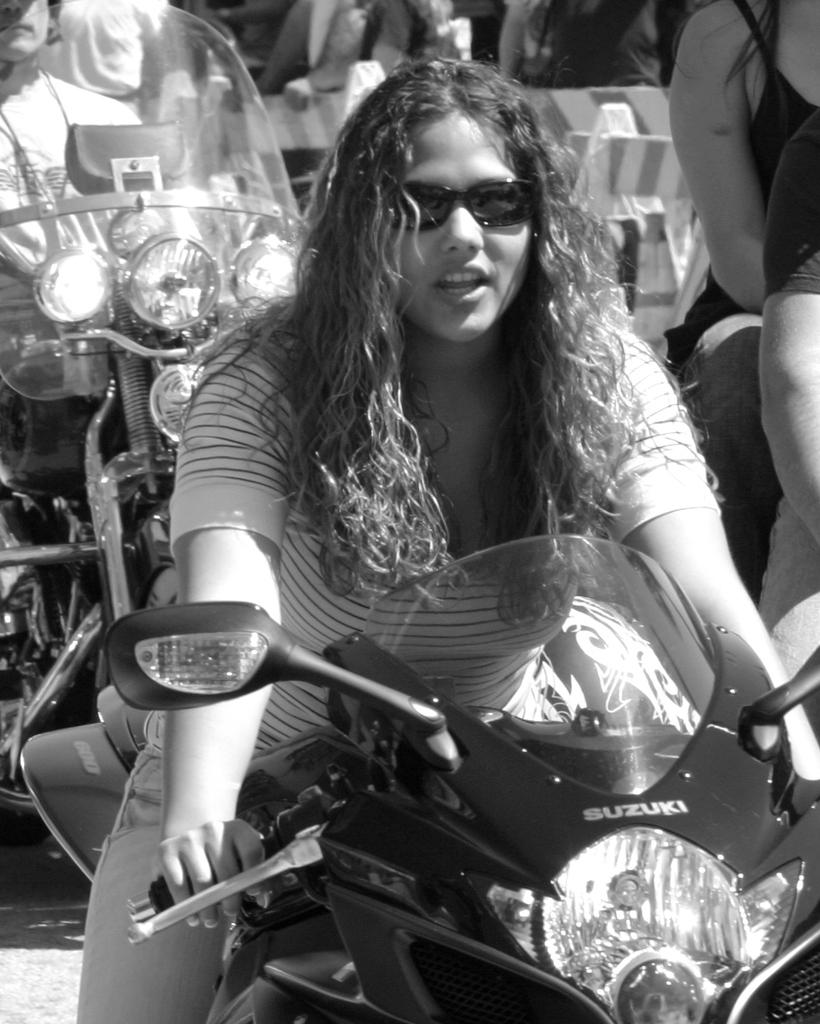What is the main subject of the image? The main subject of the image is a lady. What is the lady doing in the image? The lady is riding a motorcycle in the image. Can you describe the lady's appearance? The lady is wearing spectacles in the image. What type of idea can be seen in the image? There is no idea present in the image; it features a lady riding a motorcycle while wearing spectacles. Can you point out the bears in the image? There are no bears present in the image. 